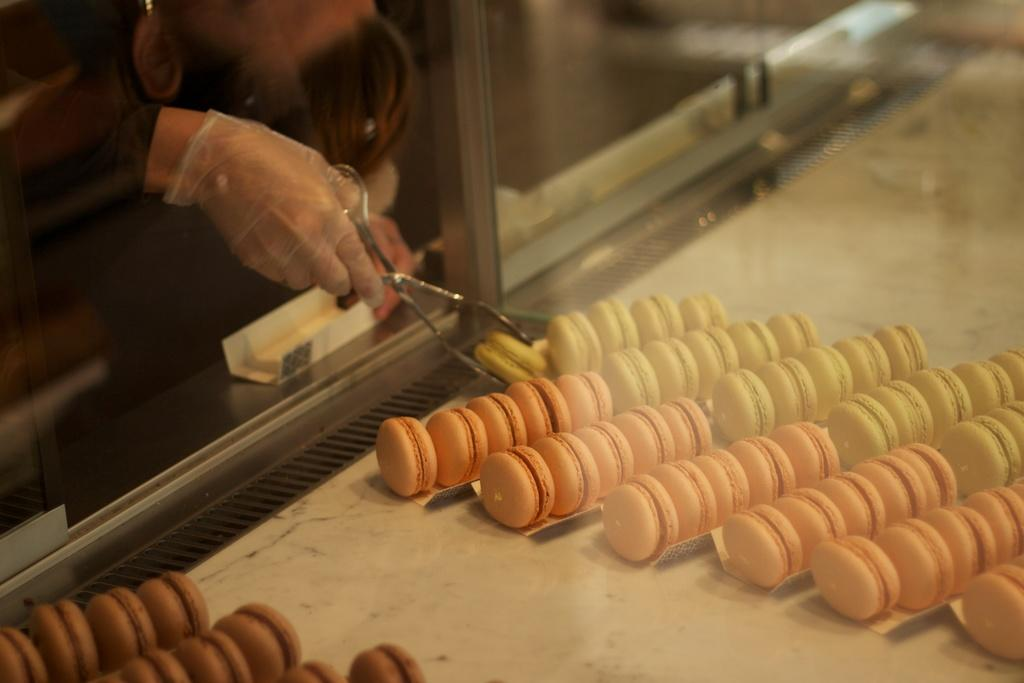What is the main piece of furniture in the image? There is a table in the image. What is placed on the table? There is a glass on the table, and biscuits are placed in a row on the table. What is the person's hand holding? The person's hand is holding a biscuit and scissors. How does the person's hand help the beginner learn to bubble in the image? There is no mention of a beginner or bubbling in the image; the person's hand is holding a biscuit and scissors. 